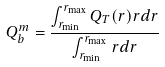<formula> <loc_0><loc_0><loc_500><loc_500>Q _ { b } ^ { m } = \frac { \int _ { r _ { \min } } ^ { r _ { \max } } Q _ { T } ( r ) r d r } { \int _ { r _ { \min } } ^ { r _ { \max } } r d r }</formula> 